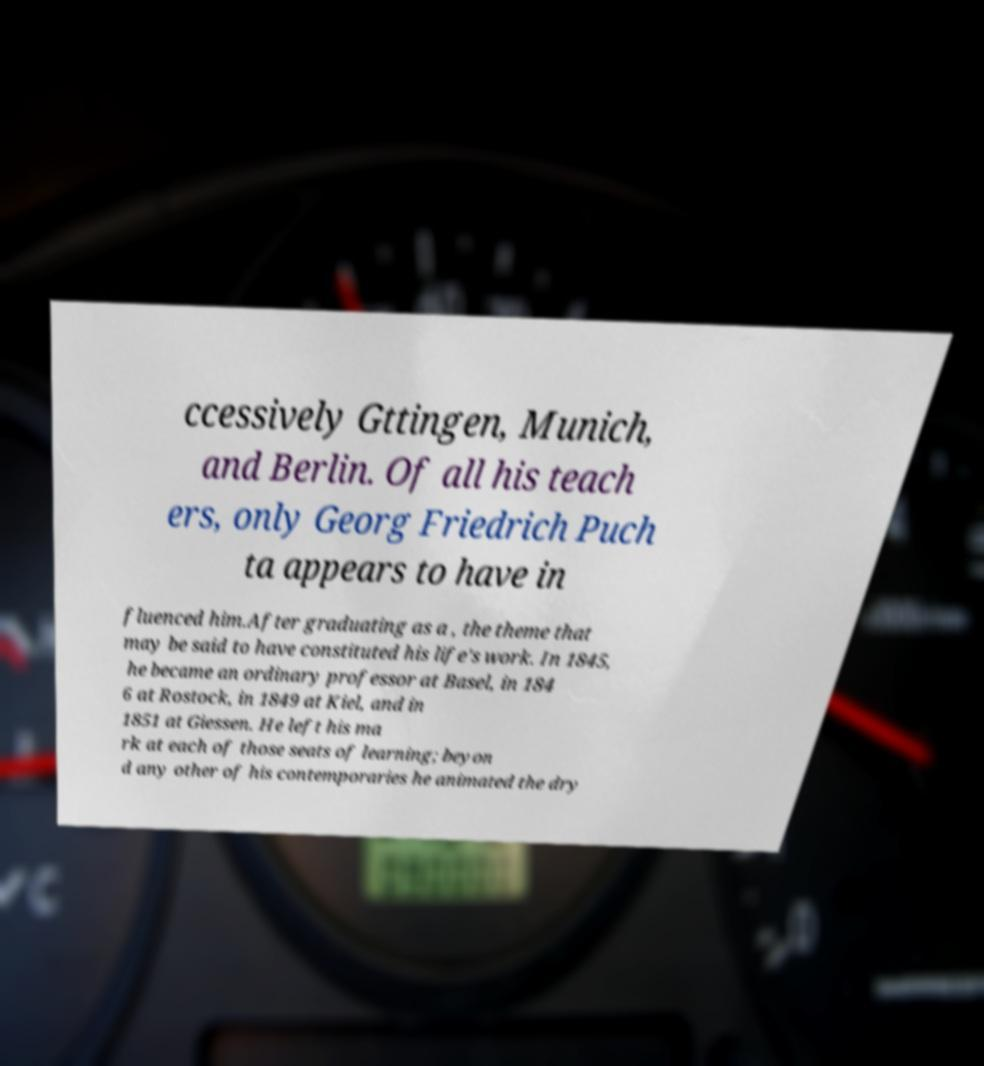What messages or text are displayed in this image? I need them in a readable, typed format. ccessively Gttingen, Munich, and Berlin. Of all his teach ers, only Georg Friedrich Puch ta appears to have in fluenced him.After graduating as a , the theme that may be said to have constituted his life's work. In 1845, he became an ordinary professor at Basel, in 184 6 at Rostock, in 1849 at Kiel, and in 1851 at Giessen. He left his ma rk at each of those seats of learning; beyon d any other of his contemporaries he animated the dry 